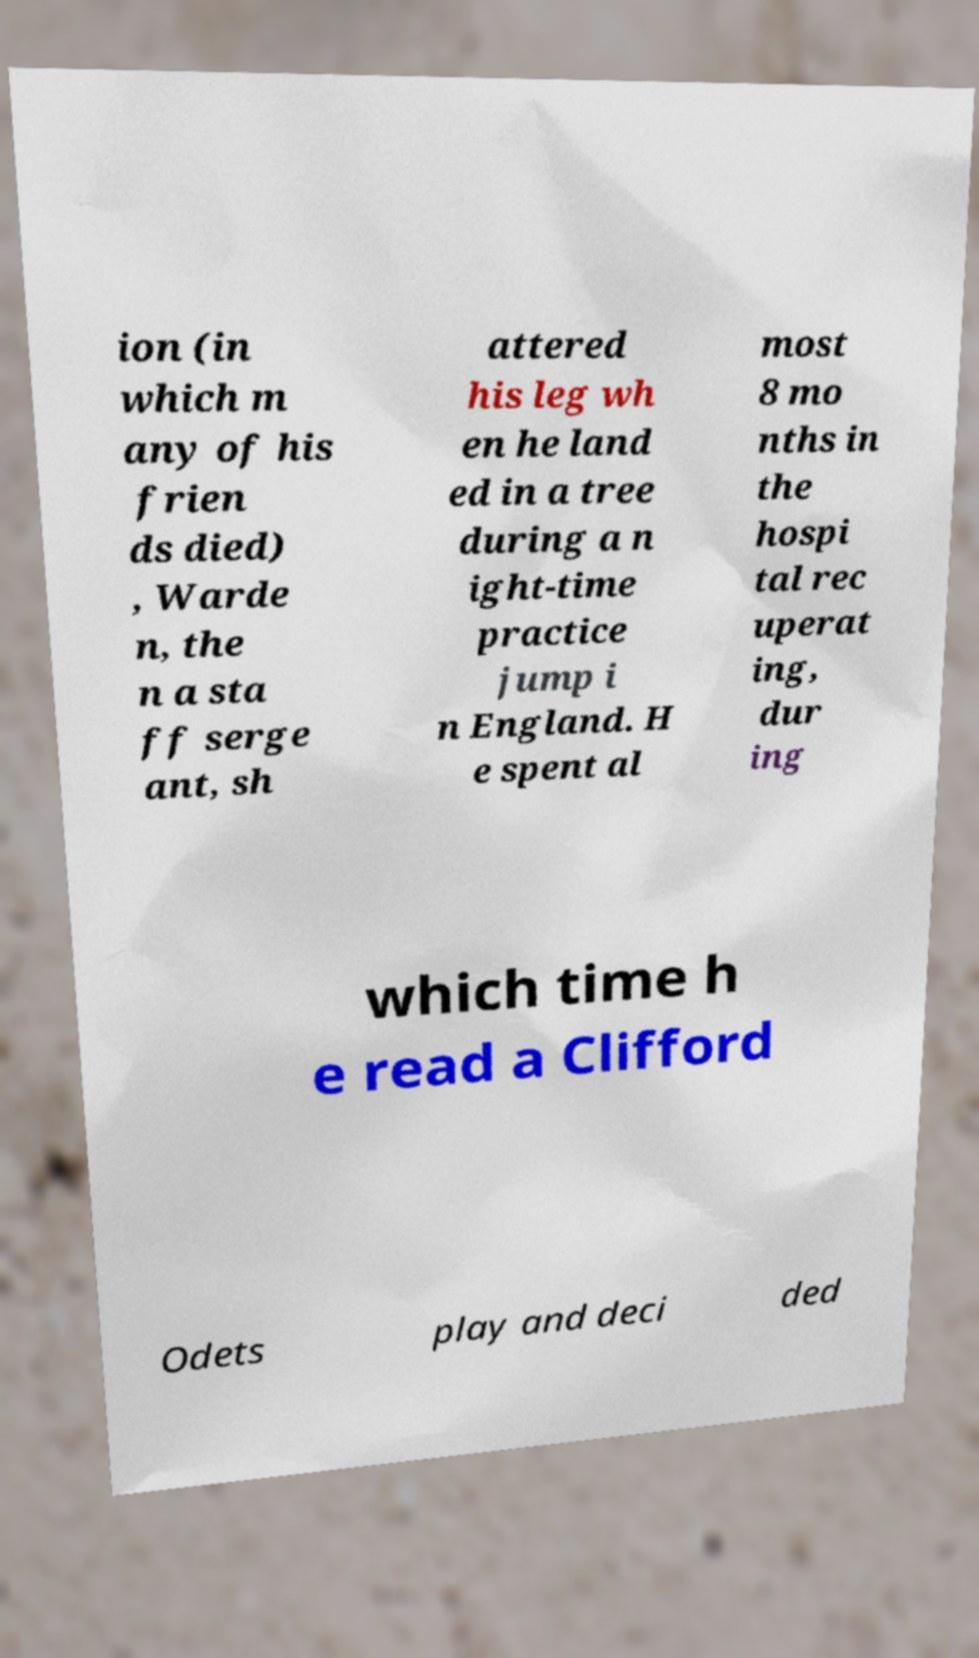Could you extract and type out the text from this image? ion (in which m any of his frien ds died) , Warde n, the n a sta ff serge ant, sh attered his leg wh en he land ed in a tree during a n ight-time practice jump i n England. H e spent al most 8 mo nths in the hospi tal rec uperat ing, dur ing which time h e read a Clifford Odets play and deci ded 